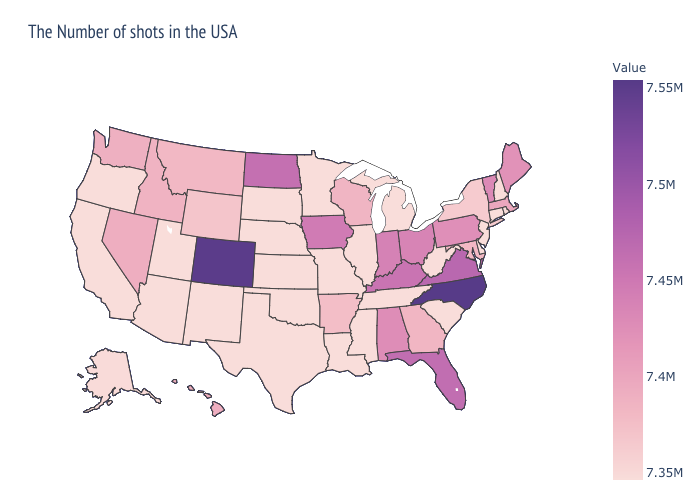Does Texas have the highest value in the USA?
Short answer required. No. Is the legend a continuous bar?
Write a very short answer. Yes. Does North Carolina have the highest value in the South?
Keep it brief. Yes. Does New Jersey have a higher value than Hawaii?
Concise answer only. No. Which states have the lowest value in the USA?
Short answer required. Rhode Island, New Hampshire, Connecticut, New Jersey, Delaware, South Carolina, West Virginia, Michigan, Tennessee, Illinois, Mississippi, Louisiana, Missouri, Minnesota, Kansas, Nebraska, Oklahoma, Texas, South Dakota, New Mexico, Utah, Arizona, California, Oregon. Is the legend a continuous bar?
Write a very short answer. Yes. Among the states that border Connecticut , which have the highest value?
Answer briefly. Massachusetts. 